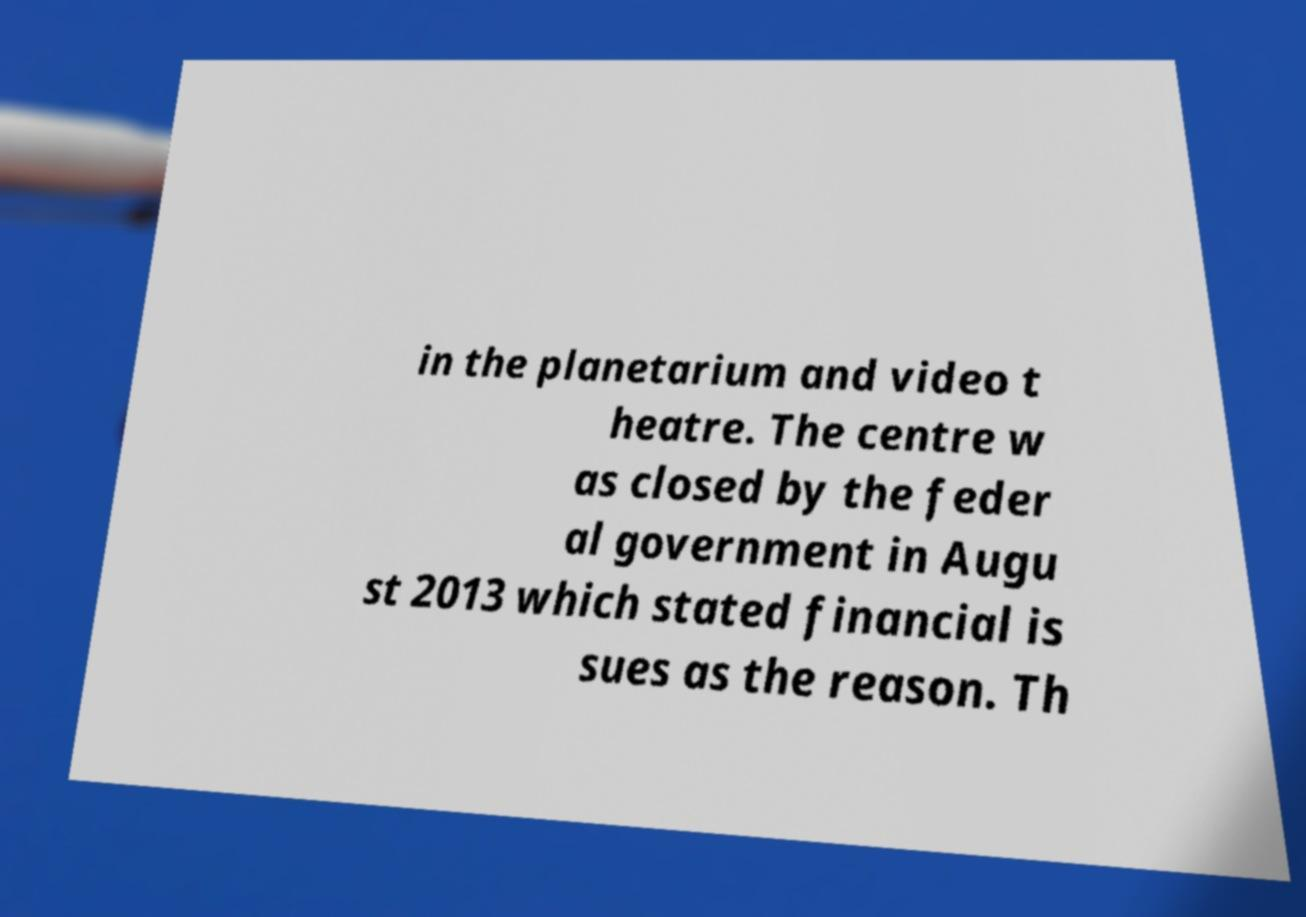For documentation purposes, I need the text within this image transcribed. Could you provide that? in the planetarium and video t heatre. The centre w as closed by the feder al government in Augu st 2013 which stated financial is sues as the reason. Th 